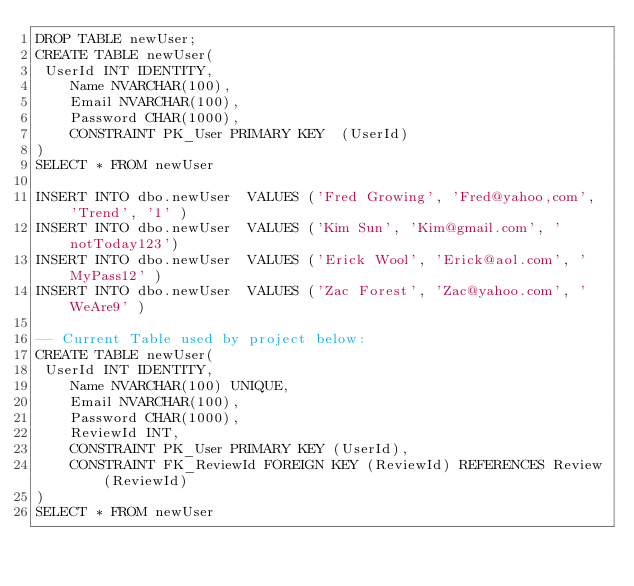Convert code to text. <code><loc_0><loc_0><loc_500><loc_500><_SQL_>DROP TABLE newUser;
CREATE TABLE newUser(
 UserId INT IDENTITY,
    Name NVARCHAR(100),
    Email NVARCHAR(100),
    Password CHAR(1000),
    CONSTRAINT PK_User PRIMARY KEY  (UserId)
)
SELECT * FROM newUser

INSERT INTO dbo.newUser  VALUES ('Fred Growing', 'Fred@yahoo,com', 'Trend', '1' ) 
INSERT INTO dbo.newUser  VALUES ('Kim Sun', 'Kim@gmail.com', 'notToday123') 
INSERT INTO dbo.newUser  VALUES ('Erick Wool', 'Erick@aol.com', 'MyPass12' ) 
INSERT INTO dbo.newUser  VALUES ('Zac Forest', 'Zac@yahoo.com', 'WeAre9' ) 

-- Current Table used by project below:
CREATE TABLE newUser(
 UserId INT IDENTITY,
    Name NVARCHAR(100) UNIQUE,
    Email NVARCHAR(100),
    Password CHAR(1000),
    ReviewId INT,
    CONSTRAINT PK_User PRIMARY KEY (UserId),
    CONSTRAINT FK_ReviewId FOREIGN KEY (ReviewId) REFERENCES Review(ReviewId)
)
SELECT * FROM newUser</code> 